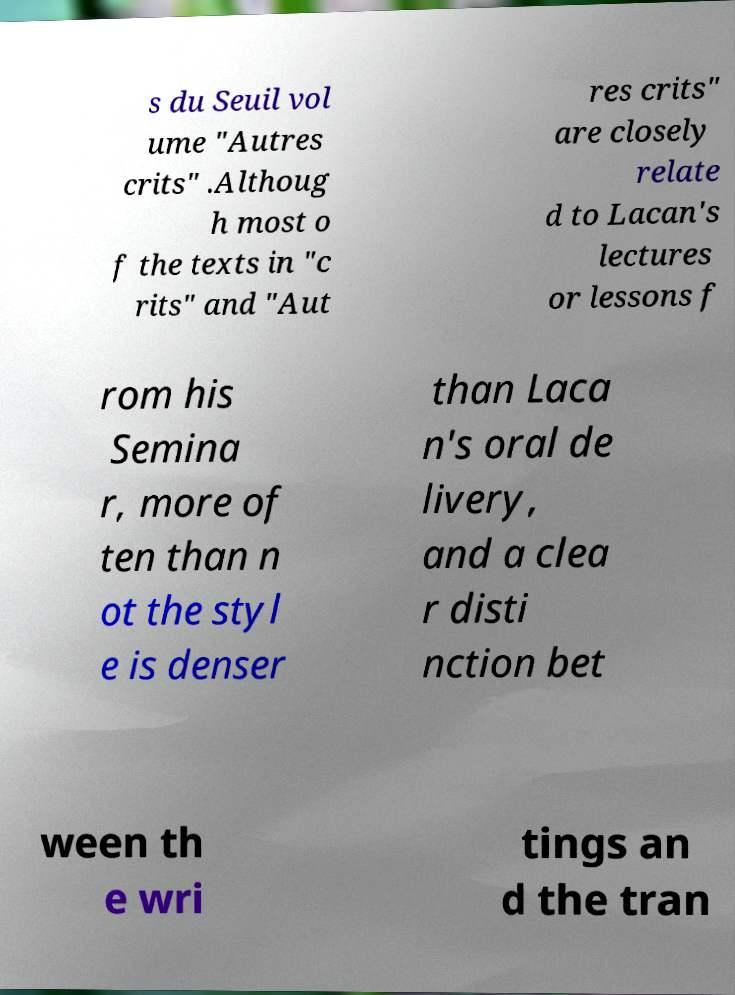What messages or text are displayed in this image? I need them in a readable, typed format. s du Seuil vol ume "Autres crits" .Althoug h most o f the texts in "c rits" and "Aut res crits" are closely relate d to Lacan's lectures or lessons f rom his Semina r, more of ten than n ot the styl e is denser than Laca n's oral de livery, and a clea r disti nction bet ween th e wri tings an d the tran 